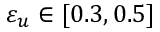Convert formula to latex. <formula><loc_0><loc_0><loc_500><loc_500>\varepsilon _ { u } \in [ 0 . 3 , 0 . 5 ]</formula> 